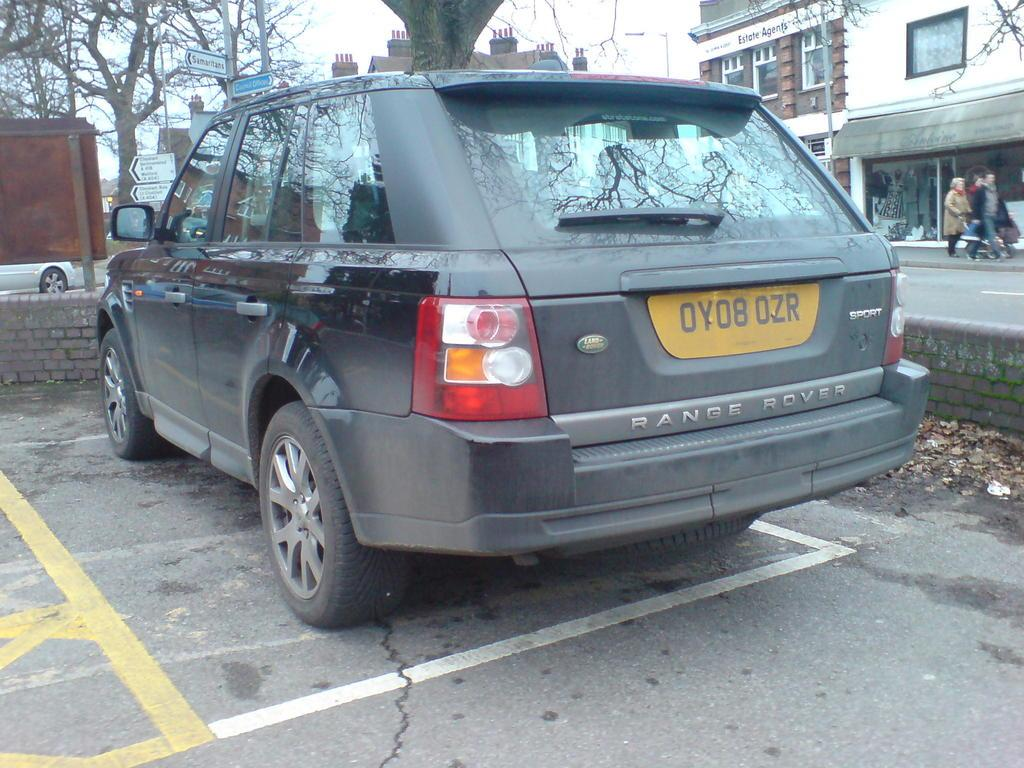What is the main subject of the image? The main subject of the image is a car. Can you describe the car's position in the image? The car is on a surface in the image. What other objects can be seen in the image? There is a wall, trees, boards on poles, people, buildings, and the sky visible in the image. What type of behavior can be observed in the clock in the image? There is no clock present in the image, so no behavior can be observed. 